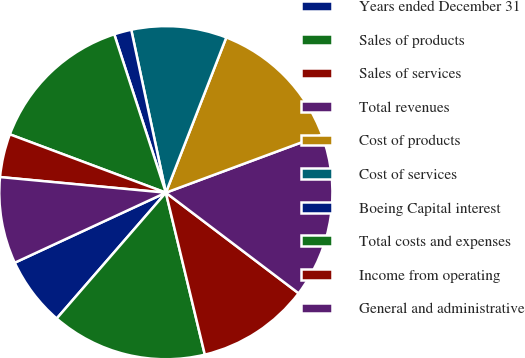Convert chart. <chart><loc_0><loc_0><loc_500><loc_500><pie_chart><fcel>Years ended December 31<fcel>Sales of products<fcel>Sales of services<fcel>Total revenues<fcel>Cost of products<fcel>Cost of services<fcel>Boeing Capital interest<fcel>Total costs and expenses<fcel>Income from operating<fcel>General and administrative<nl><fcel>6.72%<fcel>15.13%<fcel>10.92%<fcel>15.97%<fcel>13.44%<fcel>9.24%<fcel>1.68%<fcel>14.29%<fcel>4.2%<fcel>8.4%<nl></chart> 